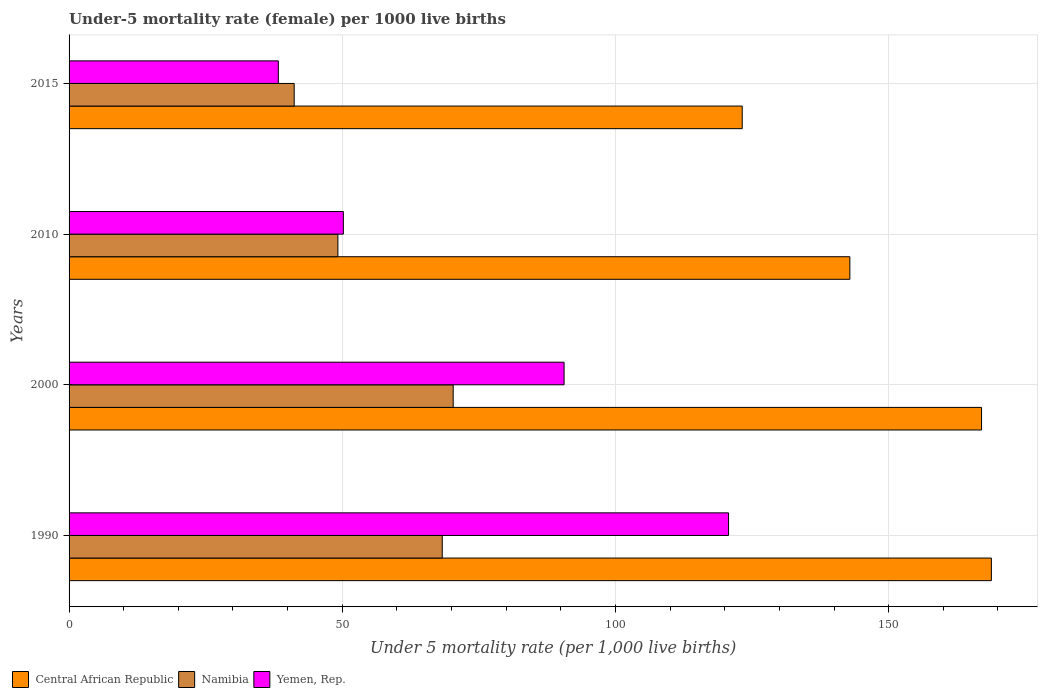Are the number of bars on each tick of the Y-axis equal?
Offer a terse response. Yes. How many bars are there on the 4th tick from the top?
Make the answer very short. 3. What is the label of the 3rd group of bars from the top?
Your answer should be very brief. 2000. What is the under-five mortality rate in Namibia in 2015?
Provide a short and direct response. 41.2. Across all years, what is the maximum under-five mortality rate in Central African Republic?
Give a very brief answer. 168.8. Across all years, what is the minimum under-five mortality rate in Yemen, Rep.?
Offer a very short reply. 38.3. In which year was the under-five mortality rate in Central African Republic maximum?
Make the answer very short. 1990. In which year was the under-five mortality rate in Central African Republic minimum?
Provide a short and direct response. 2015. What is the total under-five mortality rate in Namibia in the graph?
Offer a very short reply. 229. What is the difference between the under-five mortality rate in Namibia in 2000 and that in 2010?
Your response must be concise. 21.1. What is the difference between the under-five mortality rate in Namibia in 2000 and the under-five mortality rate in Yemen, Rep. in 2015?
Make the answer very short. 32. What is the average under-five mortality rate in Yemen, Rep. per year?
Provide a succinct answer. 74.95. In the year 2000, what is the difference between the under-five mortality rate in Yemen, Rep. and under-five mortality rate in Namibia?
Make the answer very short. 20.3. In how many years, is the under-five mortality rate in Yemen, Rep. greater than 110 ?
Keep it short and to the point. 1. What is the ratio of the under-five mortality rate in Yemen, Rep. in 1990 to that in 2015?
Ensure brevity in your answer.  3.15. What is the difference between the highest and the second highest under-five mortality rate in Central African Republic?
Provide a succinct answer. 1.8. What is the difference between the highest and the lowest under-five mortality rate in Namibia?
Offer a very short reply. 29.1. What does the 1st bar from the top in 2000 represents?
Keep it short and to the point. Yemen, Rep. What does the 1st bar from the bottom in 2015 represents?
Offer a very short reply. Central African Republic. Is it the case that in every year, the sum of the under-five mortality rate in Yemen, Rep. and under-five mortality rate in Central African Republic is greater than the under-five mortality rate in Namibia?
Make the answer very short. Yes. How many bars are there?
Give a very brief answer. 12. Are all the bars in the graph horizontal?
Your answer should be compact. Yes. What is the difference between two consecutive major ticks on the X-axis?
Make the answer very short. 50. Are the values on the major ticks of X-axis written in scientific E-notation?
Provide a short and direct response. No. Does the graph contain any zero values?
Your answer should be very brief. No. Does the graph contain grids?
Your response must be concise. Yes. Where does the legend appear in the graph?
Keep it short and to the point. Bottom left. How many legend labels are there?
Ensure brevity in your answer.  3. What is the title of the graph?
Provide a short and direct response. Under-5 mortality rate (female) per 1000 live births. What is the label or title of the X-axis?
Keep it short and to the point. Under 5 mortality rate (per 1,0 live births). What is the label or title of the Y-axis?
Your response must be concise. Years. What is the Under 5 mortality rate (per 1,000 live births) in Central African Republic in 1990?
Offer a very short reply. 168.8. What is the Under 5 mortality rate (per 1,000 live births) in Namibia in 1990?
Provide a short and direct response. 68.3. What is the Under 5 mortality rate (per 1,000 live births) in Yemen, Rep. in 1990?
Ensure brevity in your answer.  120.7. What is the Under 5 mortality rate (per 1,000 live births) in Central African Republic in 2000?
Make the answer very short. 167. What is the Under 5 mortality rate (per 1,000 live births) of Namibia in 2000?
Your response must be concise. 70.3. What is the Under 5 mortality rate (per 1,000 live births) in Yemen, Rep. in 2000?
Give a very brief answer. 90.6. What is the Under 5 mortality rate (per 1,000 live births) in Central African Republic in 2010?
Ensure brevity in your answer.  142.9. What is the Under 5 mortality rate (per 1,000 live births) of Namibia in 2010?
Provide a succinct answer. 49.2. What is the Under 5 mortality rate (per 1,000 live births) in Yemen, Rep. in 2010?
Offer a very short reply. 50.2. What is the Under 5 mortality rate (per 1,000 live births) in Central African Republic in 2015?
Your answer should be compact. 123.2. What is the Under 5 mortality rate (per 1,000 live births) of Namibia in 2015?
Provide a succinct answer. 41.2. What is the Under 5 mortality rate (per 1,000 live births) of Yemen, Rep. in 2015?
Your answer should be compact. 38.3. Across all years, what is the maximum Under 5 mortality rate (per 1,000 live births) in Central African Republic?
Make the answer very short. 168.8. Across all years, what is the maximum Under 5 mortality rate (per 1,000 live births) in Namibia?
Make the answer very short. 70.3. Across all years, what is the maximum Under 5 mortality rate (per 1,000 live births) of Yemen, Rep.?
Your answer should be very brief. 120.7. Across all years, what is the minimum Under 5 mortality rate (per 1,000 live births) of Central African Republic?
Offer a terse response. 123.2. Across all years, what is the minimum Under 5 mortality rate (per 1,000 live births) in Namibia?
Ensure brevity in your answer.  41.2. Across all years, what is the minimum Under 5 mortality rate (per 1,000 live births) of Yemen, Rep.?
Your answer should be compact. 38.3. What is the total Under 5 mortality rate (per 1,000 live births) in Central African Republic in the graph?
Keep it short and to the point. 601.9. What is the total Under 5 mortality rate (per 1,000 live births) in Namibia in the graph?
Make the answer very short. 229. What is the total Under 5 mortality rate (per 1,000 live births) in Yemen, Rep. in the graph?
Offer a very short reply. 299.8. What is the difference between the Under 5 mortality rate (per 1,000 live births) of Yemen, Rep. in 1990 and that in 2000?
Your answer should be compact. 30.1. What is the difference between the Under 5 mortality rate (per 1,000 live births) in Central African Republic in 1990 and that in 2010?
Offer a terse response. 25.9. What is the difference between the Under 5 mortality rate (per 1,000 live births) in Yemen, Rep. in 1990 and that in 2010?
Your answer should be very brief. 70.5. What is the difference between the Under 5 mortality rate (per 1,000 live births) in Central African Republic in 1990 and that in 2015?
Your response must be concise. 45.6. What is the difference between the Under 5 mortality rate (per 1,000 live births) of Namibia in 1990 and that in 2015?
Your response must be concise. 27.1. What is the difference between the Under 5 mortality rate (per 1,000 live births) of Yemen, Rep. in 1990 and that in 2015?
Provide a short and direct response. 82.4. What is the difference between the Under 5 mortality rate (per 1,000 live births) of Central African Republic in 2000 and that in 2010?
Keep it short and to the point. 24.1. What is the difference between the Under 5 mortality rate (per 1,000 live births) of Namibia in 2000 and that in 2010?
Provide a succinct answer. 21.1. What is the difference between the Under 5 mortality rate (per 1,000 live births) of Yemen, Rep. in 2000 and that in 2010?
Ensure brevity in your answer.  40.4. What is the difference between the Under 5 mortality rate (per 1,000 live births) of Central African Republic in 2000 and that in 2015?
Provide a short and direct response. 43.8. What is the difference between the Under 5 mortality rate (per 1,000 live births) in Namibia in 2000 and that in 2015?
Your answer should be compact. 29.1. What is the difference between the Under 5 mortality rate (per 1,000 live births) of Yemen, Rep. in 2000 and that in 2015?
Ensure brevity in your answer.  52.3. What is the difference between the Under 5 mortality rate (per 1,000 live births) of Central African Republic in 2010 and that in 2015?
Your answer should be compact. 19.7. What is the difference between the Under 5 mortality rate (per 1,000 live births) of Namibia in 2010 and that in 2015?
Keep it short and to the point. 8. What is the difference between the Under 5 mortality rate (per 1,000 live births) of Yemen, Rep. in 2010 and that in 2015?
Your answer should be compact. 11.9. What is the difference between the Under 5 mortality rate (per 1,000 live births) in Central African Republic in 1990 and the Under 5 mortality rate (per 1,000 live births) in Namibia in 2000?
Offer a terse response. 98.5. What is the difference between the Under 5 mortality rate (per 1,000 live births) of Central African Republic in 1990 and the Under 5 mortality rate (per 1,000 live births) of Yemen, Rep. in 2000?
Make the answer very short. 78.2. What is the difference between the Under 5 mortality rate (per 1,000 live births) of Namibia in 1990 and the Under 5 mortality rate (per 1,000 live births) of Yemen, Rep. in 2000?
Offer a terse response. -22.3. What is the difference between the Under 5 mortality rate (per 1,000 live births) in Central African Republic in 1990 and the Under 5 mortality rate (per 1,000 live births) in Namibia in 2010?
Offer a very short reply. 119.6. What is the difference between the Under 5 mortality rate (per 1,000 live births) in Central African Republic in 1990 and the Under 5 mortality rate (per 1,000 live births) in Yemen, Rep. in 2010?
Give a very brief answer. 118.6. What is the difference between the Under 5 mortality rate (per 1,000 live births) in Central African Republic in 1990 and the Under 5 mortality rate (per 1,000 live births) in Namibia in 2015?
Your answer should be very brief. 127.6. What is the difference between the Under 5 mortality rate (per 1,000 live births) in Central African Republic in 1990 and the Under 5 mortality rate (per 1,000 live births) in Yemen, Rep. in 2015?
Make the answer very short. 130.5. What is the difference between the Under 5 mortality rate (per 1,000 live births) of Central African Republic in 2000 and the Under 5 mortality rate (per 1,000 live births) of Namibia in 2010?
Provide a succinct answer. 117.8. What is the difference between the Under 5 mortality rate (per 1,000 live births) of Central African Republic in 2000 and the Under 5 mortality rate (per 1,000 live births) of Yemen, Rep. in 2010?
Offer a very short reply. 116.8. What is the difference between the Under 5 mortality rate (per 1,000 live births) in Namibia in 2000 and the Under 5 mortality rate (per 1,000 live births) in Yemen, Rep. in 2010?
Your answer should be compact. 20.1. What is the difference between the Under 5 mortality rate (per 1,000 live births) of Central African Republic in 2000 and the Under 5 mortality rate (per 1,000 live births) of Namibia in 2015?
Offer a very short reply. 125.8. What is the difference between the Under 5 mortality rate (per 1,000 live births) of Central African Republic in 2000 and the Under 5 mortality rate (per 1,000 live births) of Yemen, Rep. in 2015?
Keep it short and to the point. 128.7. What is the difference between the Under 5 mortality rate (per 1,000 live births) of Central African Republic in 2010 and the Under 5 mortality rate (per 1,000 live births) of Namibia in 2015?
Offer a very short reply. 101.7. What is the difference between the Under 5 mortality rate (per 1,000 live births) of Central African Republic in 2010 and the Under 5 mortality rate (per 1,000 live births) of Yemen, Rep. in 2015?
Give a very brief answer. 104.6. What is the difference between the Under 5 mortality rate (per 1,000 live births) of Namibia in 2010 and the Under 5 mortality rate (per 1,000 live births) of Yemen, Rep. in 2015?
Make the answer very short. 10.9. What is the average Under 5 mortality rate (per 1,000 live births) of Central African Republic per year?
Provide a succinct answer. 150.47. What is the average Under 5 mortality rate (per 1,000 live births) in Namibia per year?
Your answer should be compact. 57.25. What is the average Under 5 mortality rate (per 1,000 live births) of Yemen, Rep. per year?
Provide a short and direct response. 74.95. In the year 1990, what is the difference between the Under 5 mortality rate (per 1,000 live births) in Central African Republic and Under 5 mortality rate (per 1,000 live births) in Namibia?
Offer a very short reply. 100.5. In the year 1990, what is the difference between the Under 5 mortality rate (per 1,000 live births) in Central African Republic and Under 5 mortality rate (per 1,000 live births) in Yemen, Rep.?
Keep it short and to the point. 48.1. In the year 1990, what is the difference between the Under 5 mortality rate (per 1,000 live births) in Namibia and Under 5 mortality rate (per 1,000 live births) in Yemen, Rep.?
Your response must be concise. -52.4. In the year 2000, what is the difference between the Under 5 mortality rate (per 1,000 live births) in Central African Republic and Under 5 mortality rate (per 1,000 live births) in Namibia?
Provide a short and direct response. 96.7. In the year 2000, what is the difference between the Under 5 mortality rate (per 1,000 live births) in Central African Republic and Under 5 mortality rate (per 1,000 live births) in Yemen, Rep.?
Your response must be concise. 76.4. In the year 2000, what is the difference between the Under 5 mortality rate (per 1,000 live births) in Namibia and Under 5 mortality rate (per 1,000 live births) in Yemen, Rep.?
Ensure brevity in your answer.  -20.3. In the year 2010, what is the difference between the Under 5 mortality rate (per 1,000 live births) of Central African Republic and Under 5 mortality rate (per 1,000 live births) of Namibia?
Keep it short and to the point. 93.7. In the year 2010, what is the difference between the Under 5 mortality rate (per 1,000 live births) in Central African Republic and Under 5 mortality rate (per 1,000 live births) in Yemen, Rep.?
Offer a terse response. 92.7. In the year 2010, what is the difference between the Under 5 mortality rate (per 1,000 live births) of Namibia and Under 5 mortality rate (per 1,000 live births) of Yemen, Rep.?
Offer a very short reply. -1. In the year 2015, what is the difference between the Under 5 mortality rate (per 1,000 live births) of Central African Republic and Under 5 mortality rate (per 1,000 live births) of Yemen, Rep.?
Your response must be concise. 84.9. In the year 2015, what is the difference between the Under 5 mortality rate (per 1,000 live births) of Namibia and Under 5 mortality rate (per 1,000 live births) of Yemen, Rep.?
Provide a short and direct response. 2.9. What is the ratio of the Under 5 mortality rate (per 1,000 live births) of Central African Republic in 1990 to that in 2000?
Your answer should be compact. 1.01. What is the ratio of the Under 5 mortality rate (per 1,000 live births) of Namibia in 1990 to that in 2000?
Offer a very short reply. 0.97. What is the ratio of the Under 5 mortality rate (per 1,000 live births) of Yemen, Rep. in 1990 to that in 2000?
Your answer should be very brief. 1.33. What is the ratio of the Under 5 mortality rate (per 1,000 live births) in Central African Republic in 1990 to that in 2010?
Keep it short and to the point. 1.18. What is the ratio of the Under 5 mortality rate (per 1,000 live births) in Namibia in 1990 to that in 2010?
Provide a short and direct response. 1.39. What is the ratio of the Under 5 mortality rate (per 1,000 live births) of Yemen, Rep. in 1990 to that in 2010?
Your answer should be compact. 2.4. What is the ratio of the Under 5 mortality rate (per 1,000 live births) of Central African Republic in 1990 to that in 2015?
Your answer should be compact. 1.37. What is the ratio of the Under 5 mortality rate (per 1,000 live births) in Namibia in 1990 to that in 2015?
Your response must be concise. 1.66. What is the ratio of the Under 5 mortality rate (per 1,000 live births) in Yemen, Rep. in 1990 to that in 2015?
Offer a very short reply. 3.15. What is the ratio of the Under 5 mortality rate (per 1,000 live births) in Central African Republic in 2000 to that in 2010?
Keep it short and to the point. 1.17. What is the ratio of the Under 5 mortality rate (per 1,000 live births) in Namibia in 2000 to that in 2010?
Ensure brevity in your answer.  1.43. What is the ratio of the Under 5 mortality rate (per 1,000 live births) in Yemen, Rep. in 2000 to that in 2010?
Offer a terse response. 1.8. What is the ratio of the Under 5 mortality rate (per 1,000 live births) of Central African Republic in 2000 to that in 2015?
Your answer should be compact. 1.36. What is the ratio of the Under 5 mortality rate (per 1,000 live births) in Namibia in 2000 to that in 2015?
Offer a very short reply. 1.71. What is the ratio of the Under 5 mortality rate (per 1,000 live births) of Yemen, Rep. in 2000 to that in 2015?
Keep it short and to the point. 2.37. What is the ratio of the Under 5 mortality rate (per 1,000 live births) in Central African Republic in 2010 to that in 2015?
Give a very brief answer. 1.16. What is the ratio of the Under 5 mortality rate (per 1,000 live births) of Namibia in 2010 to that in 2015?
Make the answer very short. 1.19. What is the ratio of the Under 5 mortality rate (per 1,000 live births) in Yemen, Rep. in 2010 to that in 2015?
Give a very brief answer. 1.31. What is the difference between the highest and the second highest Under 5 mortality rate (per 1,000 live births) in Central African Republic?
Give a very brief answer. 1.8. What is the difference between the highest and the second highest Under 5 mortality rate (per 1,000 live births) of Yemen, Rep.?
Offer a terse response. 30.1. What is the difference between the highest and the lowest Under 5 mortality rate (per 1,000 live births) in Central African Republic?
Ensure brevity in your answer.  45.6. What is the difference between the highest and the lowest Under 5 mortality rate (per 1,000 live births) in Namibia?
Ensure brevity in your answer.  29.1. What is the difference between the highest and the lowest Under 5 mortality rate (per 1,000 live births) in Yemen, Rep.?
Keep it short and to the point. 82.4. 